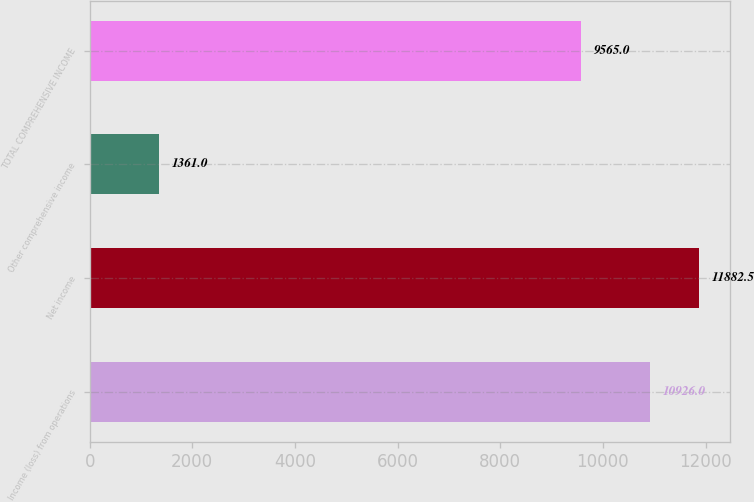Convert chart. <chart><loc_0><loc_0><loc_500><loc_500><bar_chart><fcel>Income (loss) from operations<fcel>Net income<fcel>Other comprehensive income<fcel>TOTAL COMPREHENSIVE INCOME<nl><fcel>10926<fcel>11882.5<fcel>1361<fcel>9565<nl></chart> 